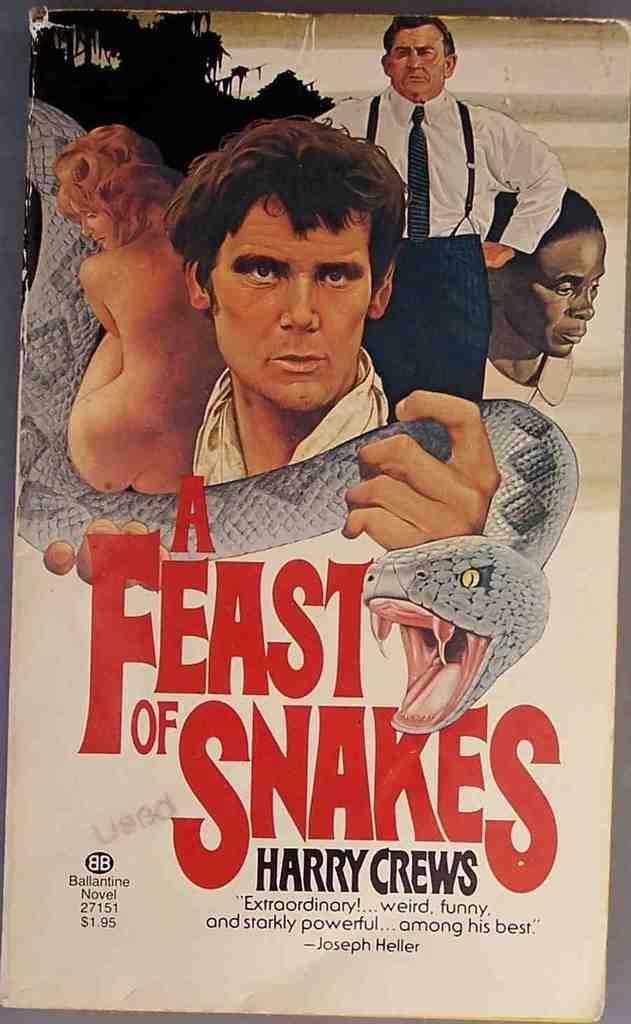<image>
Provide a brief description of the given image. Harry Crews stars in a book titled A Feat of Snakes that features three men and a naked woman on the cover 